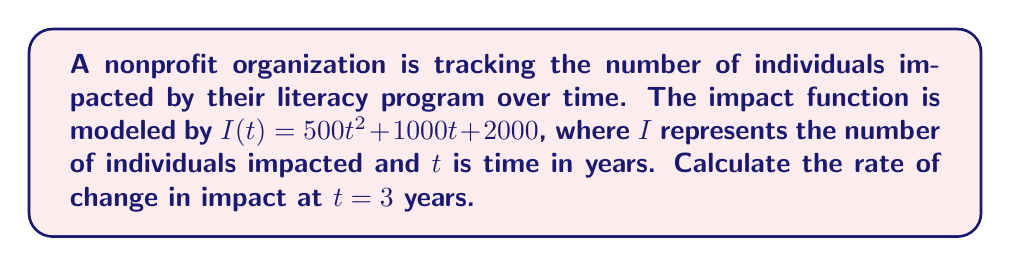Solve this math problem. To find the rate of change in impact at a specific point in time, we need to calculate the derivative of the impact function and evaluate it at the given time.

Step 1: Identify the impact function
$I(t) = 500t^2 + 1000t + 2000$

Step 2: Calculate the derivative of $I(t)$
Using the power rule and constant rule of differentiation:
$$\frac{dI}{dt} = 1000t + 1000$$

This derivative represents the instantaneous rate of change of impact with respect to time.

Step 3: Evaluate the derivative at $t = 3$
$$\frac{dI}{dt}\bigg|_{t=3} = 1000(3) + 1000 = 3000 + 1000 = 4000$$

Therefore, at $t = 3$ years, the rate of change in impact is 4000 individuals per year.
Answer: 4000 individuals/year 